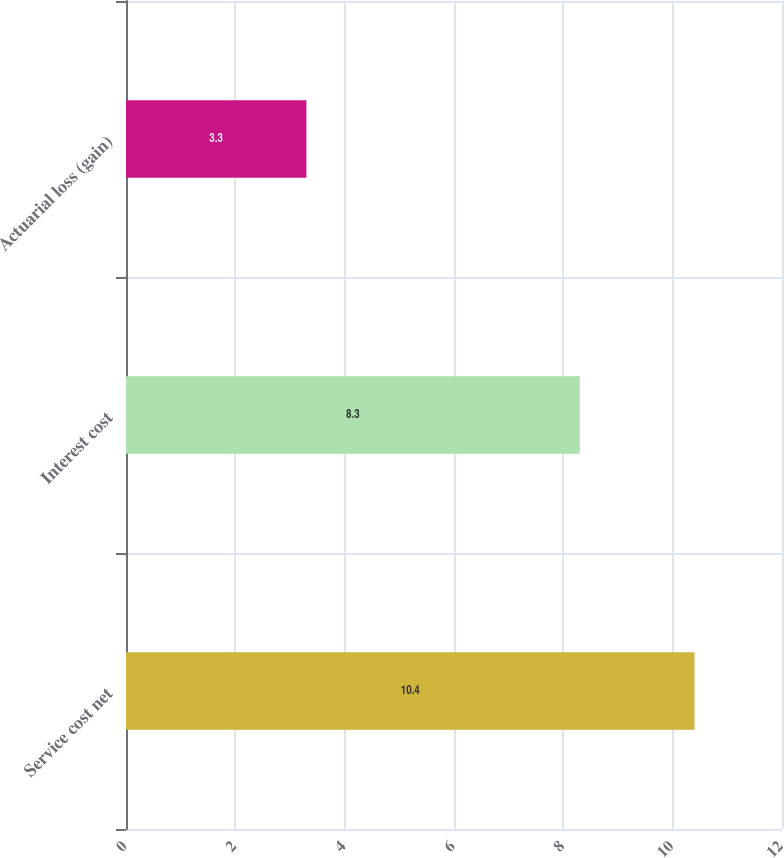Convert chart to OTSL. <chart><loc_0><loc_0><loc_500><loc_500><bar_chart><fcel>Service cost net<fcel>Interest cost<fcel>Actuarial loss (gain)<nl><fcel>10.4<fcel>8.3<fcel>3.3<nl></chart> 